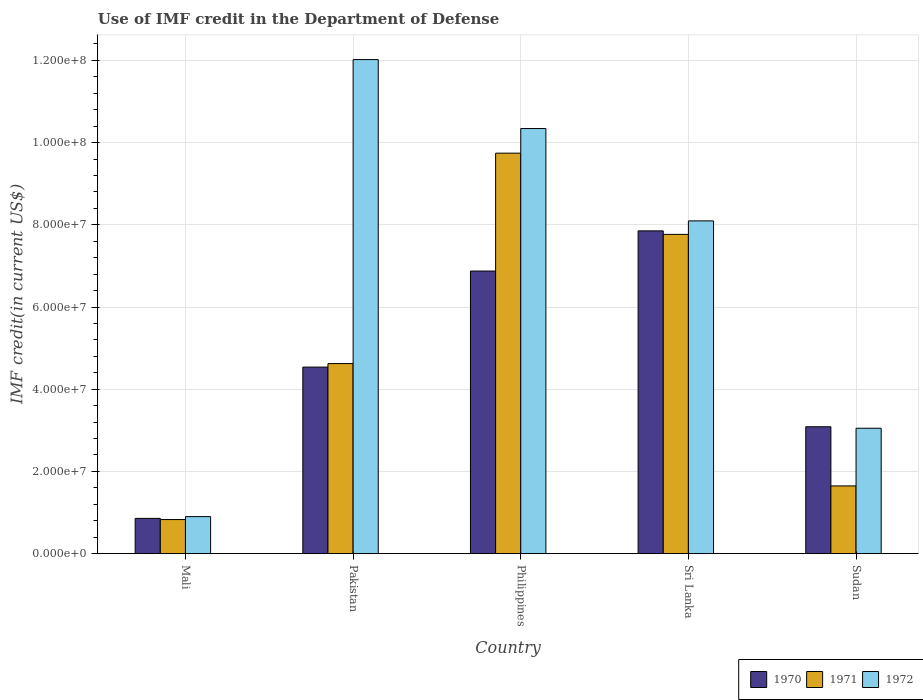How many different coloured bars are there?
Make the answer very short. 3. How many groups of bars are there?
Give a very brief answer. 5. How many bars are there on the 3rd tick from the left?
Make the answer very short. 3. What is the label of the 4th group of bars from the left?
Keep it short and to the point. Sri Lanka. What is the IMF credit in the Department of Defense in 1972 in Sudan?
Offer a very short reply. 3.05e+07. Across all countries, what is the maximum IMF credit in the Department of Defense in 1970?
Make the answer very short. 7.85e+07. Across all countries, what is the minimum IMF credit in the Department of Defense in 1972?
Give a very brief answer. 9.01e+06. In which country was the IMF credit in the Department of Defense in 1971 maximum?
Provide a short and direct response. Philippines. In which country was the IMF credit in the Department of Defense in 1971 minimum?
Provide a short and direct response. Mali. What is the total IMF credit in the Department of Defense in 1971 in the graph?
Offer a terse response. 2.46e+08. What is the difference between the IMF credit in the Department of Defense in 1972 in Pakistan and that in Sudan?
Provide a short and direct response. 8.97e+07. What is the difference between the IMF credit in the Department of Defense in 1970 in Pakistan and the IMF credit in the Department of Defense in 1972 in Sri Lanka?
Make the answer very short. -3.56e+07. What is the average IMF credit in the Department of Defense in 1972 per country?
Make the answer very short. 6.88e+07. What is the difference between the IMF credit in the Department of Defense of/in 1972 and IMF credit in the Department of Defense of/in 1970 in Sri Lanka?
Provide a short and direct response. 2.43e+06. What is the ratio of the IMF credit in the Department of Defense in 1972 in Mali to that in Philippines?
Keep it short and to the point. 0.09. Is the difference between the IMF credit in the Department of Defense in 1972 in Mali and Philippines greater than the difference between the IMF credit in the Department of Defense in 1970 in Mali and Philippines?
Provide a succinct answer. No. What is the difference between the highest and the second highest IMF credit in the Department of Defense in 1972?
Keep it short and to the point. 1.68e+07. What is the difference between the highest and the lowest IMF credit in the Department of Defense in 1970?
Provide a succinct answer. 6.99e+07. In how many countries, is the IMF credit in the Department of Defense in 1970 greater than the average IMF credit in the Department of Defense in 1970 taken over all countries?
Give a very brief answer. 2. Is the sum of the IMF credit in the Department of Defense in 1970 in Mali and Philippines greater than the maximum IMF credit in the Department of Defense in 1971 across all countries?
Your answer should be compact. No. What does the 2nd bar from the left in Sudan represents?
Keep it short and to the point. 1971. What does the 1st bar from the right in Sri Lanka represents?
Provide a succinct answer. 1972. Is it the case that in every country, the sum of the IMF credit in the Department of Defense in 1971 and IMF credit in the Department of Defense in 1972 is greater than the IMF credit in the Department of Defense in 1970?
Provide a succinct answer. Yes. Does the graph contain any zero values?
Your answer should be very brief. No. Where does the legend appear in the graph?
Make the answer very short. Bottom right. How are the legend labels stacked?
Your answer should be very brief. Horizontal. What is the title of the graph?
Your answer should be compact. Use of IMF credit in the Department of Defense. Does "2005" appear as one of the legend labels in the graph?
Offer a terse response. No. What is the label or title of the Y-axis?
Give a very brief answer. IMF credit(in current US$). What is the IMF credit(in current US$) of 1970 in Mali?
Make the answer very short. 8.58e+06. What is the IMF credit(in current US$) in 1971 in Mali?
Keep it short and to the point. 8.30e+06. What is the IMF credit(in current US$) of 1972 in Mali?
Offer a terse response. 9.01e+06. What is the IMF credit(in current US$) of 1970 in Pakistan?
Keep it short and to the point. 4.54e+07. What is the IMF credit(in current US$) of 1971 in Pakistan?
Your answer should be very brief. 4.62e+07. What is the IMF credit(in current US$) of 1972 in Pakistan?
Give a very brief answer. 1.20e+08. What is the IMF credit(in current US$) in 1970 in Philippines?
Your answer should be very brief. 6.88e+07. What is the IMF credit(in current US$) of 1971 in Philippines?
Ensure brevity in your answer.  9.74e+07. What is the IMF credit(in current US$) in 1972 in Philippines?
Make the answer very short. 1.03e+08. What is the IMF credit(in current US$) of 1970 in Sri Lanka?
Offer a very short reply. 7.85e+07. What is the IMF credit(in current US$) in 1971 in Sri Lanka?
Ensure brevity in your answer.  7.77e+07. What is the IMF credit(in current US$) in 1972 in Sri Lanka?
Make the answer very short. 8.10e+07. What is the IMF credit(in current US$) in 1970 in Sudan?
Keep it short and to the point. 3.09e+07. What is the IMF credit(in current US$) of 1971 in Sudan?
Your response must be concise. 1.65e+07. What is the IMF credit(in current US$) of 1972 in Sudan?
Provide a succinct answer. 3.05e+07. Across all countries, what is the maximum IMF credit(in current US$) in 1970?
Provide a succinct answer. 7.85e+07. Across all countries, what is the maximum IMF credit(in current US$) in 1971?
Make the answer very short. 9.74e+07. Across all countries, what is the maximum IMF credit(in current US$) in 1972?
Provide a short and direct response. 1.20e+08. Across all countries, what is the minimum IMF credit(in current US$) of 1970?
Offer a very short reply. 8.58e+06. Across all countries, what is the minimum IMF credit(in current US$) in 1971?
Ensure brevity in your answer.  8.30e+06. Across all countries, what is the minimum IMF credit(in current US$) of 1972?
Give a very brief answer. 9.01e+06. What is the total IMF credit(in current US$) of 1970 in the graph?
Give a very brief answer. 2.32e+08. What is the total IMF credit(in current US$) in 1971 in the graph?
Provide a succinct answer. 2.46e+08. What is the total IMF credit(in current US$) of 1972 in the graph?
Your answer should be very brief. 3.44e+08. What is the difference between the IMF credit(in current US$) of 1970 in Mali and that in Pakistan?
Make the answer very short. -3.68e+07. What is the difference between the IMF credit(in current US$) of 1971 in Mali and that in Pakistan?
Your answer should be very brief. -3.79e+07. What is the difference between the IMF credit(in current US$) of 1972 in Mali and that in Pakistan?
Keep it short and to the point. -1.11e+08. What is the difference between the IMF credit(in current US$) in 1970 in Mali and that in Philippines?
Provide a succinct answer. -6.02e+07. What is the difference between the IMF credit(in current US$) in 1971 in Mali and that in Philippines?
Your answer should be compact. -8.91e+07. What is the difference between the IMF credit(in current US$) in 1972 in Mali and that in Philippines?
Ensure brevity in your answer.  -9.44e+07. What is the difference between the IMF credit(in current US$) of 1970 in Mali and that in Sri Lanka?
Make the answer very short. -6.99e+07. What is the difference between the IMF credit(in current US$) of 1971 in Mali and that in Sri Lanka?
Offer a terse response. -6.94e+07. What is the difference between the IMF credit(in current US$) in 1972 in Mali and that in Sri Lanka?
Make the answer very short. -7.19e+07. What is the difference between the IMF credit(in current US$) in 1970 in Mali and that in Sudan?
Provide a succinct answer. -2.23e+07. What is the difference between the IMF credit(in current US$) of 1971 in Mali and that in Sudan?
Your response must be concise. -8.19e+06. What is the difference between the IMF credit(in current US$) of 1972 in Mali and that in Sudan?
Offer a very short reply. -2.15e+07. What is the difference between the IMF credit(in current US$) in 1970 in Pakistan and that in Philippines?
Offer a very short reply. -2.34e+07. What is the difference between the IMF credit(in current US$) of 1971 in Pakistan and that in Philippines?
Your response must be concise. -5.12e+07. What is the difference between the IMF credit(in current US$) of 1972 in Pakistan and that in Philippines?
Provide a succinct answer. 1.68e+07. What is the difference between the IMF credit(in current US$) in 1970 in Pakistan and that in Sri Lanka?
Offer a terse response. -3.31e+07. What is the difference between the IMF credit(in current US$) of 1971 in Pakistan and that in Sri Lanka?
Your response must be concise. -3.14e+07. What is the difference between the IMF credit(in current US$) in 1972 in Pakistan and that in Sri Lanka?
Provide a short and direct response. 3.92e+07. What is the difference between the IMF credit(in current US$) of 1970 in Pakistan and that in Sudan?
Your answer should be compact. 1.45e+07. What is the difference between the IMF credit(in current US$) of 1971 in Pakistan and that in Sudan?
Ensure brevity in your answer.  2.98e+07. What is the difference between the IMF credit(in current US$) of 1972 in Pakistan and that in Sudan?
Your response must be concise. 8.97e+07. What is the difference between the IMF credit(in current US$) of 1970 in Philippines and that in Sri Lanka?
Your answer should be very brief. -9.77e+06. What is the difference between the IMF credit(in current US$) of 1971 in Philippines and that in Sri Lanka?
Your answer should be very brief. 1.98e+07. What is the difference between the IMF credit(in current US$) in 1972 in Philippines and that in Sri Lanka?
Give a very brief answer. 2.25e+07. What is the difference between the IMF credit(in current US$) in 1970 in Philippines and that in Sudan?
Your response must be concise. 3.79e+07. What is the difference between the IMF credit(in current US$) of 1971 in Philippines and that in Sudan?
Your answer should be compact. 8.09e+07. What is the difference between the IMF credit(in current US$) in 1972 in Philippines and that in Sudan?
Offer a terse response. 7.29e+07. What is the difference between the IMF credit(in current US$) in 1970 in Sri Lanka and that in Sudan?
Give a very brief answer. 4.76e+07. What is the difference between the IMF credit(in current US$) of 1971 in Sri Lanka and that in Sudan?
Provide a succinct answer. 6.12e+07. What is the difference between the IMF credit(in current US$) of 1972 in Sri Lanka and that in Sudan?
Provide a succinct answer. 5.04e+07. What is the difference between the IMF credit(in current US$) in 1970 in Mali and the IMF credit(in current US$) in 1971 in Pakistan?
Keep it short and to the point. -3.77e+07. What is the difference between the IMF credit(in current US$) in 1970 in Mali and the IMF credit(in current US$) in 1972 in Pakistan?
Keep it short and to the point. -1.12e+08. What is the difference between the IMF credit(in current US$) of 1971 in Mali and the IMF credit(in current US$) of 1972 in Pakistan?
Provide a succinct answer. -1.12e+08. What is the difference between the IMF credit(in current US$) in 1970 in Mali and the IMF credit(in current US$) in 1971 in Philippines?
Provide a short and direct response. -8.88e+07. What is the difference between the IMF credit(in current US$) of 1970 in Mali and the IMF credit(in current US$) of 1972 in Philippines?
Your answer should be very brief. -9.48e+07. What is the difference between the IMF credit(in current US$) of 1971 in Mali and the IMF credit(in current US$) of 1972 in Philippines?
Give a very brief answer. -9.51e+07. What is the difference between the IMF credit(in current US$) in 1970 in Mali and the IMF credit(in current US$) in 1971 in Sri Lanka?
Offer a very short reply. -6.91e+07. What is the difference between the IMF credit(in current US$) in 1970 in Mali and the IMF credit(in current US$) in 1972 in Sri Lanka?
Provide a short and direct response. -7.24e+07. What is the difference between the IMF credit(in current US$) in 1971 in Mali and the IMF credit(in current US$) in 1972 in Sri Lanka?
Your answer should be compact. -7.27e+07. What is the difference between the IMF credit(in current US$) of 1970 in Mali and the IMF credit(in current US$) of 1971 in Sudan?
Give a very brief answer. -7.90e+06. What is the difference between the IMF credit(in current US$) in 1970 in Mali and the IMF credit(in current US$) in 1972 in Sudan?
Ensure brevity in your answer.  -2.19e+07. What is the difference between the IMF credit(in current US$) of 1971 in Mali and the IMF credit(in current US$) of 1972 in Sudan?
Make the answer very short. -2.22e+07. What is the difference between the IMF credit(in current US$) of 1970 in Pakistan and the IMF credit(in current US$) of 1971 in Philippines?
Provide a short and direct response. -5.20e+07. What is the difference between the IMF credit(in current US$) in 1970 in Pakistan and the IMF credit(in current US$) in 1972 in Philippines?
Offer a very short reply. -5.80e+07. What is the difference between the IMF credit(in current US$) in 1971 in Pakistan and the IMF credit(in current US$) in 1972 in Philippines?
Your response must be concise. -5.72e+07. What is the difference between the IMF credit(in current US$) of 1970 in Pakistan and the IMF credit(in current US$) of 1971 in Sri Lanka?
Offer a very short reply. -3.23e+07. What is the difference between the IMF credit(in current US$) in 1970 in Pakistan and the IMF credit(in current US$) in 1972 in Sri Lanka?
Ensure brevity in your answer.  -3.56e+07. What is the difference between the IMF credit(in current US$) in 1971 in Pakistan and the IMF credit(in current US$) in 1972 in Sri Lanka?
Give a very brief answer. -3.47e+07. What is the difference between the IMF credit(in current US$) of 1970 in Pakistan and the IMF credit(in current US$) of 1971 in Sudan?
Offer a very short reply. 2.89e+07. What is the difference between the IMF credit(in current US$) in 1970 in Pakistan and the IMF credit(in current US$) in 1972 in Sudan?
Your response must be concise. 1.49e+07. What is the difference between the IMF credit(in current US$) of 1971 in Pakistan and the IMF credit(in current US$) of 1972 in Sudan?
Your answer should be compact. 1.57e+07. What is the difference between the IMF credit(in current US$) in 1970 in Philippines and the IMF credit(in current US$) in 1971 in Sri Lanka?
Your answer should be very brief. -8.91e+06. What is the difference between the IMF credit(in current US$) of 1970 in Philippines and the IMF credit(in current US$) of 1972 in Sri Lanka?
Your answer should be very brief. -1.22e+07. What is the difference between the IMF credit(in current US$) in 1971 in Philippines and the IMF credit(in current US$) in 1972 in Sri Lanka?
Provide a succinct answer. 1.65e+07. What is the difference between the IMF credit(in current US$) of 1970 in Philippines and the IMF credit(in current US$) of 1971 in Sudan?
Make the answer very short. 5.23e+07. What is the difference between the IMF credit(in current US$) in 1970 in Philippines and the IMF credit(in current US$) in 1972 in Sudan?
Your response must be concise. 3.82e+07. What is the difference between the IMF credit(in current US$) of 1971 in Philippines and the IMF credit(in current US$) of 1972 in Sudan?
Offer a very short reply. 6.69e+07. What is the difference between the IMF credit(in current US$) of 1970 in Sri Lanka and the IMF credit(in current US$) of 1971 in Sudan?
Your answer should be compact. 6.20e+07. What is the difference between the IMF credit(in current US$) in 1970 in Sri Lanka and the IMF credit(in current US$) in 1972 in Sudan?
Offer a very short reply. 4.80e+07. What is the difference between the IMF credit(in current US$) of 1971 in Sri Lanka and the IMF credit(in current US$) of 1972 in Sudan?
Provide a succinct answer. 4.72e+07. What is the average IMF credit(in current US$) in 1970 per country?
Make the answer very short. 4.64e+07. What is the average IMF credit(in current US$) of 1971 per country?
Keep it short and to the point. 4.92e+07. What is the average IMF credit(in current US$) in 1972 per country?
Offer a very short reply. 6.88e+07. What is the difference between the IMF credit(in current US$) of 1970 and IMF credit(in current US$) of 1971 in Mali?
Offer a very short reply. 2.85e+05. What is the difference between the IMF credit(in current US$) in 1970 and IMF credit(in current US$) in 1972 in Mali?
Provide a short and direct response. -4.31e+05. What is the difference between the IMF credit(in current US$) of 1971 and IMF credit(in current US$) of 1972 in Mali?
Your answer should be very brief. -7.16e+05. What is the difference between the IMF credit(in current US$) in 1970 and IMF credit(in current US$) in 1971 in Pakistan?
Provide a succinct answer. -8.56e+05. What is the difference between the IMF credit(in current US$) in 1970 and IMF credit(in current US$) in 1972 in Pakistan?
Offer a very short reply. -7.48e+07. What is the difference between the IMF credit(in current US$) of 1971 and IMF credit(in current US$) of 1972 in Pakistan?
Your answer should be compact. -7.40e+07. What is the difference between the IMF credit(in current US$) in 1970 and IMF credit(in current US$) in 1971 in Philippines?
Offer a terse response. -2.87e+07. What is the difference between the IMF credit(in current US$) in 1970 and IMF credit(in current US$) in 1972 in Philippines?
Offer a very short reply. -3.47e+07. What is the difference between the IMF credit(in current US$) in 1971 and IMF credit(in current US$) in 1972 in Philippines?
Make the answer very short. -5.99e+06. What is the difference between the IMF credit(in current US$) in 1970 and IMF credit(in current US$) in 1971 in Sri Lanka?
Offer a very short reply. 8.56e+05. What is the difference between the IMF credit(in current US$) in 1970 and IMF credit(in current US$) in 1972 in Sri Lanka?
Your response must be concise. -2.43e+06. What is the difference between the IMF credit(in current US$) in 1971 and IMF credit(in current US$) in 1972 in Sri Lanka?
Offer a very short reply. -3.29e+06. What is the difference between the IMF credit(in current US$) in 1970 and IMF credit(in current US$) in 1971 in Sudan?
Your response must be concise. 1.44e+07. What is the difference between the IMF credit(in current US$) in 1970 and IMF credit(in current US$) in 1972 in Sudan?
Make the answer very short. 3.62e+05. What is the difference between the IMF credit(in current US$) of 1971 and IMF credit(in current US$) of 1972 in Sudan?
Give a very brief answer. -1.40e+07. What is the ratio of the IMF credit(in current US$) of 1970 in Mali to that in Pakistan?
Your answer should be compact. 0.19. What is the ratio of the IMF credit(in current US$) in 1971 in Mali to that in Pakistan?
Give a very brief answer. 0.18. What is the ratio of the IMF credit(in current US$) in 1972 in Mali to that in Pakistan?
Your answer should be very brief. 0.07. What is the ratio of the IMF credit(in current US$) of 1970 in Mali to that in Philippines?
Your response must be concise. 0.12. What is the ratio of the IMF credit(in current US$) in 1971 in Mali to that in Philippines?
Keep it short and to the point. 0.09. What is the ratio of the IMF credit(in current US$) in 1972 in Mali to that in Philippines?
Your response must be concise. 0.09. What is the ratio of the IMF credit(in current US$) in 1970 in Mali to that in Sri Lanka?
Your response must be concise. 0.11. What is the ratio of the IMF credit(in current US$) of 1971 in Mali to that in Sri Lanka?
Your answer should be compact. 0.11. What is the ratio of the IMF credit(in current US$) in 1972 in Mali to that in Sri Lanka?
Your answer should be compact. 0.11. What is the ratio of the IMF credit(in current US$) in 1970 in Mali to that in Sudan?
Offer a terse response. 0.28. What is the ratio of the IMF credit(in current US$) of 1971 in Mali to that in Sudan?
Provide a short and direct response. 0.5. What is the ratio of the IMF credit(in current US$) of 1972 in Mali to that in Sudan?
Provide a succinct answer. 0.3. What is the ratio of the IMF credit(in current US$) in 1970 in Pakistan to that in Philippines?
Your response must be concise. 0.66. What is the ratio of the IMF credit(in current US$) in 1971 in Pakistan to that in Philippines?
Make the answer very short. 0.47. What is the ratio of the IMF credit(in current US$) of 1972 in Pakistan to that in Philippines?
Ensure brevity in your answer.  1.16. What is the ratio of the IMF credit(in current US$) in 1970 in Pakistan to that in Sri Lanka?
Offer a very short reply. 0.58. What is the ratio of the IMF credit(in current US$) in 1971 in Pakistan to that in Sri Lanka?
Give a very brief answer. 0.6. What is the ratio of the IMF credit(in current US$) of 1972 in Pakistan to that in Sri Lanka?
Your answer should be very brief. 1.48. What is the ratio of the IMF credit(in current US$) in 1970 in Pakistan to that in Sudan?
Keep it short and to the point. 1.47. What is the ratio of the IMF credit(in current US$) of 1971 in Pakistan to that in Sudan?
Provide a short and direct response. 2.81. What is the ratio of the IMF credit(in current US$) in 1972 in Pakistan to that in Sudan?
Your response must be concise. 3.94. What is the ratio of the IMF credit(in current US$) of 1970 in Philippines to that in Sri Lanka?
Offer a very short reply. 0.88. What is the ratio of the IMF credit(in current US$) of 1971 in Philippines to that in Sri Lanka?
Offer a terse response. 1.25. What is the ratio of the IMF credit(in current US$) in 1972 in Philippines to that in Sri Lanka?
Your answer should be compact. 1.28. What is the ratio of the IMF credit(in current US$) of 1970 in Philippines to that in Sudan?
Offer a terse response. 2.23. What is the ratio of the IMF credit(in current US$) in 1971 in Philippines to that in Sudan?
Ensure brevity in your answer.  5.91. What is the ratio of the IMF credit(in current US$) in 1972 in Philippines to that in Sudan?
Keep it short and to the point. 3.39. What is the ratio of the IMF credit(in current US$) of 1970 in Sri Lanka to that in Sudan?
Your answer should be very brief. 2.54. What is the ratio of the IMF credit(in current US$) in 1971 in Sri Lanka to that in Sudan?
Keep it short and to the point. 4.71. What is the ratio of the IMF credit(in current US$) of 1972 in Sri Lanka to that in Sudan?
Make the answer very short. 2.65. What is the difference between the highest and the second highest IMF credit(in current US$) of 1970?
Offer a very short reply. 9.77e+06. What is the difference between the highest and the second highest IMF credit(in current US$) of 1971?
Your response must be concise. 1.98e+07. What is the difference between the highest and the second highest IMF credit(in current US$) of 1972?
Provide a succinct answer. 1.68e+07. What is the difference between the highest and the lowest IMF credit(in current US$) of 1970?
Make the answer very short. 6.99e+07. What is the difference between the highest and the lowest IMF credit(in current US$) in 1971?
Your response must be concise. 8.91e+07. What is the difference between the highest and the lowest IMF credit(in current US$) of 1972?
Offer a terse response. 1.11e+08. 